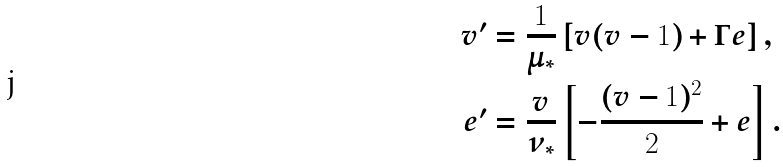Convert formula to latex. <formula><loc_0><loc_0><loc_500><loc_500>v ^ { \prime } & = \frac { 1 } { \mu _ { * } } \left [ v ( v - 1 ) + \Gamma e \right ] , \\ e ^ { \prime } & = \frac { v } { \nu _ { * } } \left [ - \frac { ( v - 1 ) ^ { 2 } } { 2 } + e \right ] .</formula> 